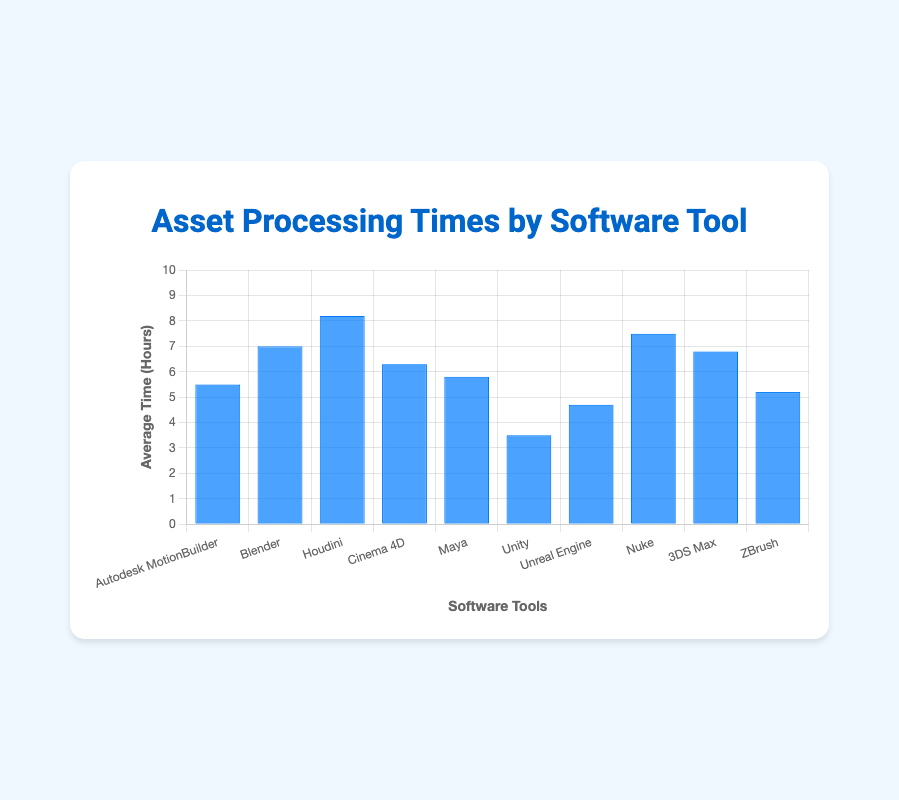Which software tool has the shortest average processing time? The bar for Unity is the shortest, indicating it has the shortest average processing time.
Answer: Unity Which software tool has the longest average processing time? The bar for Houdini is the highest, indicating it has the longest average processing time.
Answer: Houdini Which two software tools have the closest average processing times? Comparing the bars visually, Autodesk MotionBuilder and Maya have the closest average processing times (5.5 and 5.8 hours respectively).
Answer: Autodesk MotionBuilder and Maya What is the average processing time of Blender compared to Cinema 4D? The average processing time for Blender is 7.0 hours, while for Cinema 4D it is 6.3 hours. Therefore, Blender takes 0.7 hours longer on average.
Answer: 0.7 hours longer What is the total average processing time for all software tools combined? Sum all the average processing times: 5.5 + 7.0 + 8.2 + 6.3 + 5.8 + 3.5 + 4.7 + 7.5 + 6.8 + 5.2 = 60.5 hours
Answer: 60.5 hours What’s the difference in average processing time between Houdini and ZBrush? Houdini has an average processing time of 8.2 hours and ZBrush has 5.2 hours. The difference is 8.2 - 5.2 = 3.0 hours.
Answer: 3.0 hours How many software tools have an average processing time below 6 hours? The software tools with below 6 hours average processing time are Autodesk MotionBuilder, Unity, Unreal Engine, and ZBrush, totaling 4.
Answer: 4 Are there more software tools with an average processing time above or below 6 hours? There are 6 software tools with average processing times above 6 hours (Blender, Houdini, Cinema 4D, Maya, Nuke, 3DS Max) and 4 tools with below 6 hours. Therefore, more tools are above 6 hours.
Answer: Above 6 hours What is the average processing time of all software tools excluding the one with the shortest processing time? Exclude Unity (3.5 hours) and sum the rest: 57 hours / 9 tools (10 - 1) = 6.33 hours
Answer: 6.33 hours 